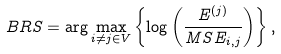Convert formula to latex. <formula><loc_0><loc_0><loc_500><loc_500>B R S = \arg \max _ { i \neq j \in V } \left \{ \log \left ( \frac { E ^ { ( j ) } } { M S E _ { i , j } } \right ) \right \} ,</formula> 